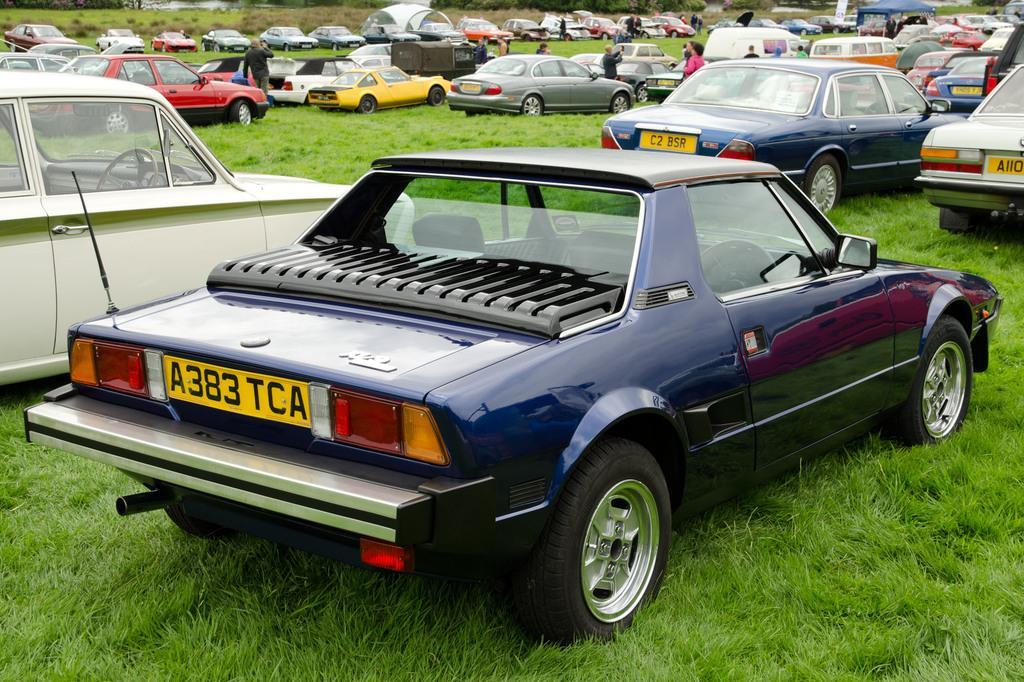Describe this image in one or two sentences. There are many cars on the grass. On the cars there are number plates. Also there are many people. 